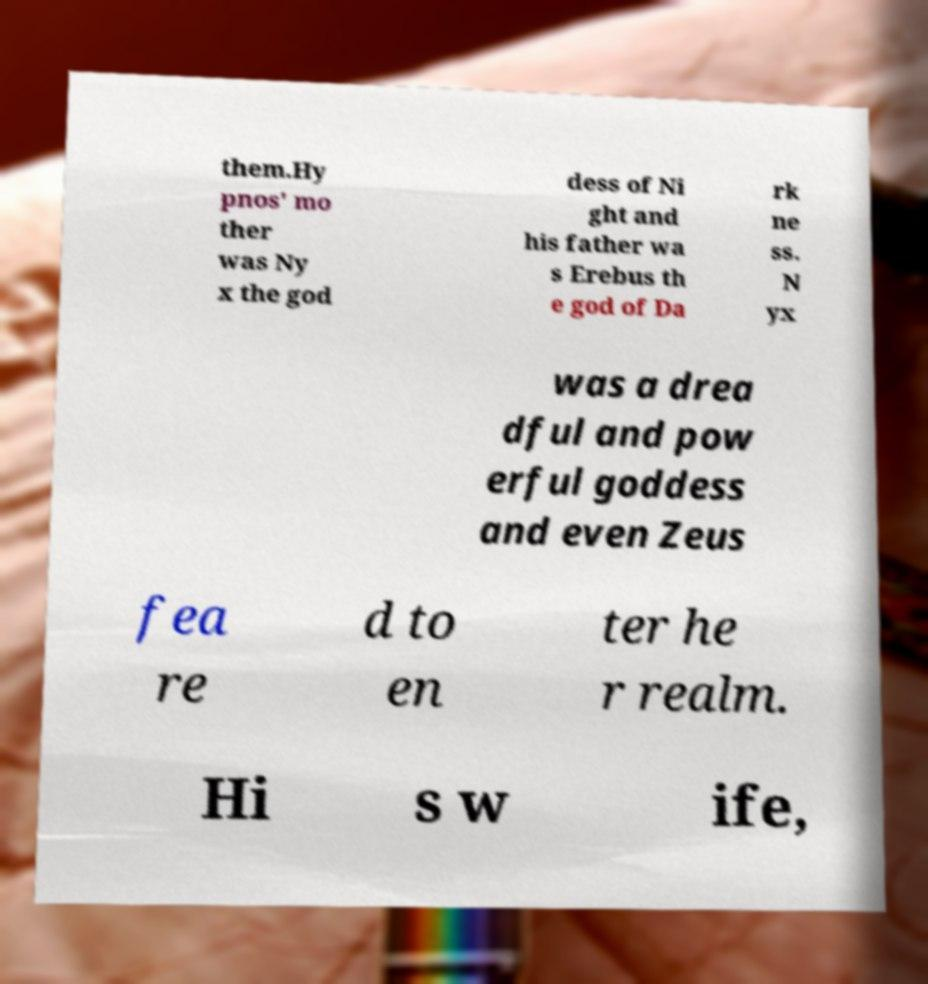What messages or text are displayed in this image? I need them in a readable, typed format. them.Hy pnos' mo ther was Ny x the god dess of Ni ght and his father wa s Erebus th e god of Da rk ne ss. N yx was a drea dful and pow erful goddess and even Zeus fea re d to en ter he r realm. Hi s w ife, 